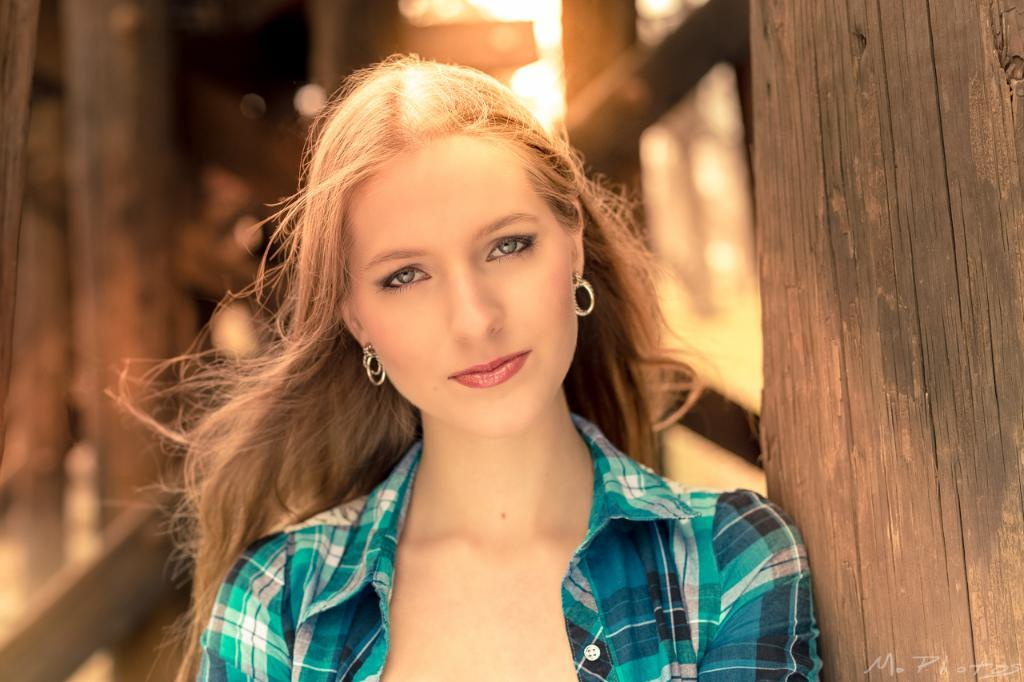Who is the main subject in the picture? There is a woman in the picture. What can be seen on the right side of the picture? There is wood on the right side of the picture. How would you describe the background of the picture? The background of the picture is blurry. Where is the text located in the picture? The text is at the bottom right corner of the picture. How many eyes can be seen pushing a loaf in the picture? There are no eyes or loaves present in the picture. 